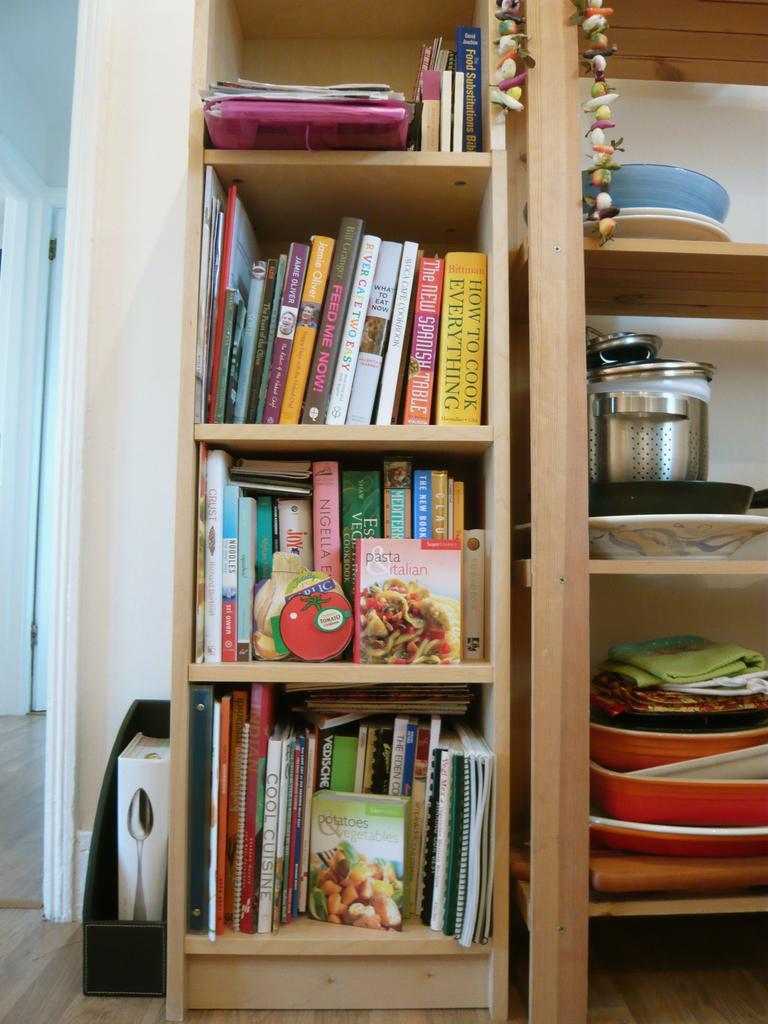Could you give a brief overview of what you see in this image? In this image we can see books are kept in the wooden cupboards and some objects are kept in the wooden shelf. Here we can see another object and another room in the background. 